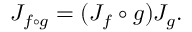Convert formula to latex. <formula><loc_0><loc_0><loc_500><loc_500>J _ { f \circ g } = ( J _ { f } \circ g ) J _ { g } .</formula> 